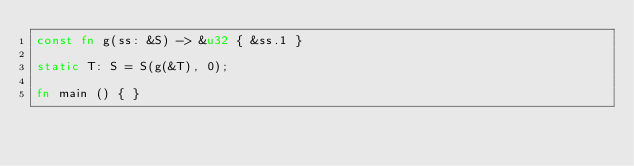Convert code to text. <code><loc_0><loc_0><loc_500><loc_500><_Rust_>const fn g(ss: &S) -> &u32 { &ss.1 }

static T: S = S(g(&T), 0);

fn main () { }
</code> 